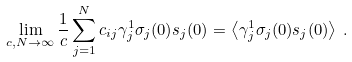<formula> <loc_0><loc_0><loc_500><loc_500>\lim _ { c , N \to \infty } \frac { 1 } { c } \sum _ { j = 1 } ^ { N } c _ { i j } \gamma _ { j } ^ { 1 } \sigma _ { j } ( 0 ) s _ { j } ( 0 ) = \left < \gamma _ { j } ^ { 1 } \sigma _ { j } ( 0 ) s _ { j } ( 0 ) \right > \, .</formula> 